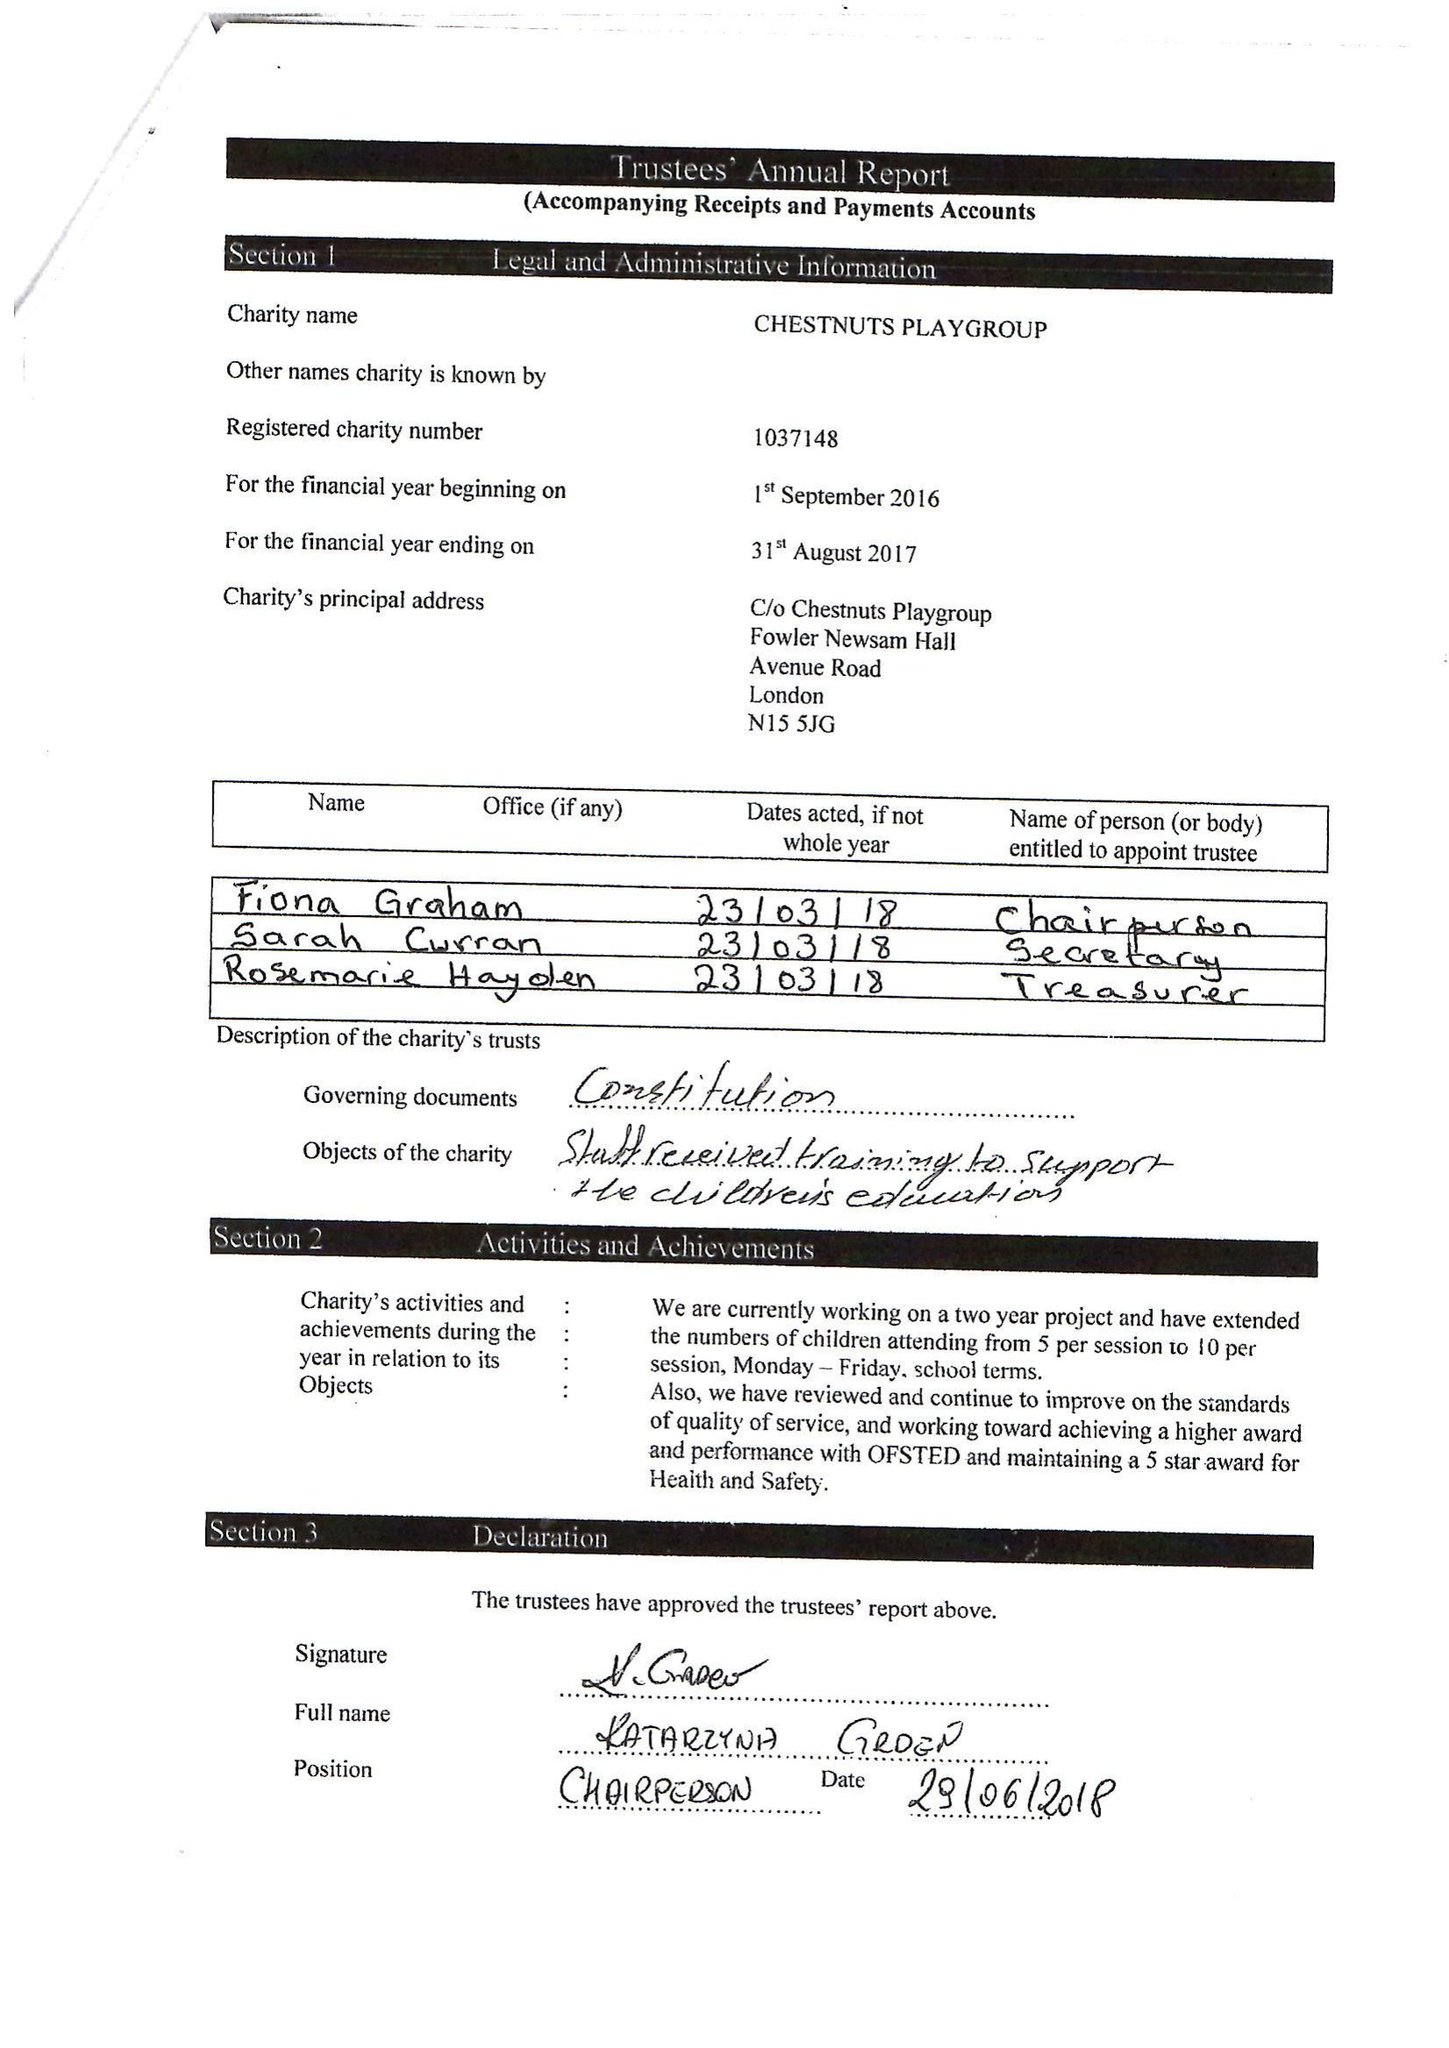What is the value for the address__street_line?
Answer the question using a single word or phrase. AVENUE ROAD 